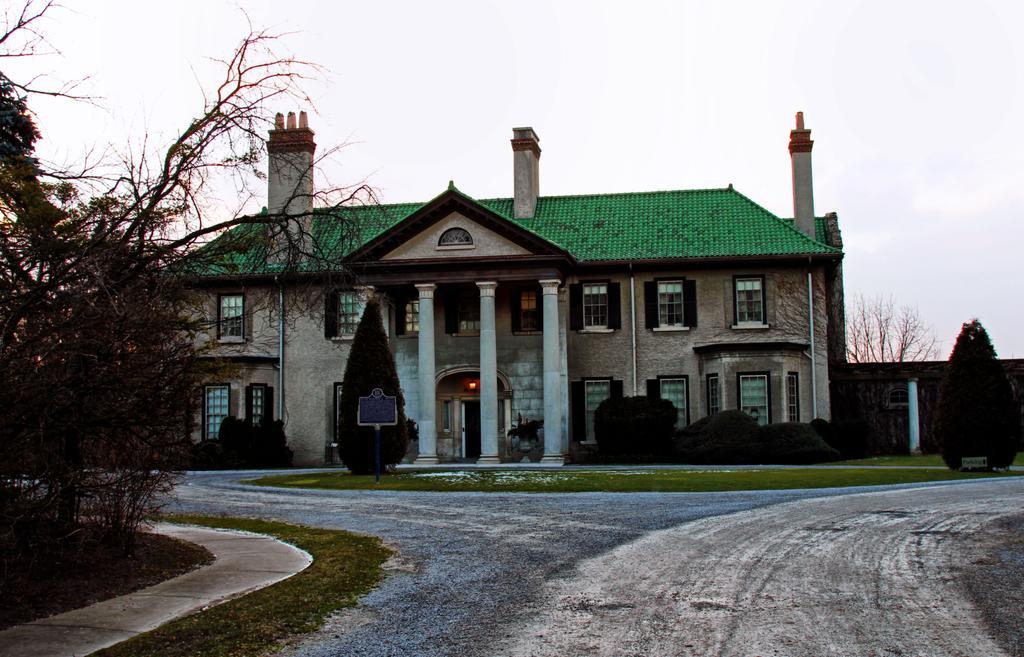Describe this image in one or two sentences. In this image we can see a building with windows and pillars. We can also see a signboard, some plants, grass, the pathway, trees and the sky which looks cloudy. 